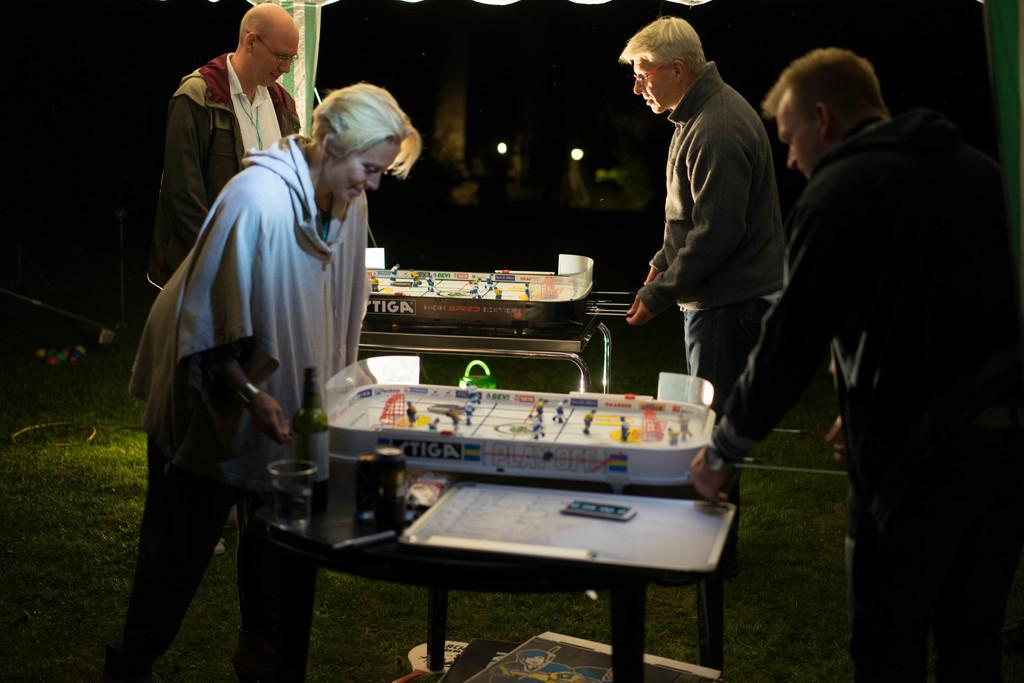How many people are standing in the image? There are four people standing in the image. What is present on the table in the image? There is a table in the image with a whiteboard, a bottle, a glass, and a game on it. What type of gold object is visible on the table in the image? There is no gold object present on the table in the image. How many friends are sitting at the table in the image? There are no friends sitting at the table in the image; the four people are standing. --- Facts: 1. There is a person holding a camera. 2. The person is standing on a bridge. 3. There is a river below the bridge. 4. There are mountains in the background. 5. The sky is visible in the image. Absurd Topics: cake, balloons, dance Conversation: What is the person holding in the image? The person is holding a camera in the image. Where is the person standing in the image? The person is standing on a bridge in the image. What can be seen below the bridge in the image? There is a river below the bridge in the image. What is visible in the background of the image? There are mountains in the background of the image. What is visible at the top of the image? The sky is visible in the image. Reasoning: Let's think step by step in order to produce the conversation. We start by identifying the main subject in the image, which is the person holding a camera. Then, we expand the conversation to include the location of the person (on a bridge), the presence of a river below the bridge, the mountains in the background, and the sky visible in the image. Each question is designed to elicit a specific detail about the image that is known from the provided facts. Absurd Question/Answer: What type of cake is being served on the bridge in the image? There is no cake present on the bridge in the image. Are there any balloons tied to the railing of the bridge in the image? There are no balloons present on the bridge in the image. Can you see any people dancing on the bridge in the image? There are no people dancing on the bridge in the image. 